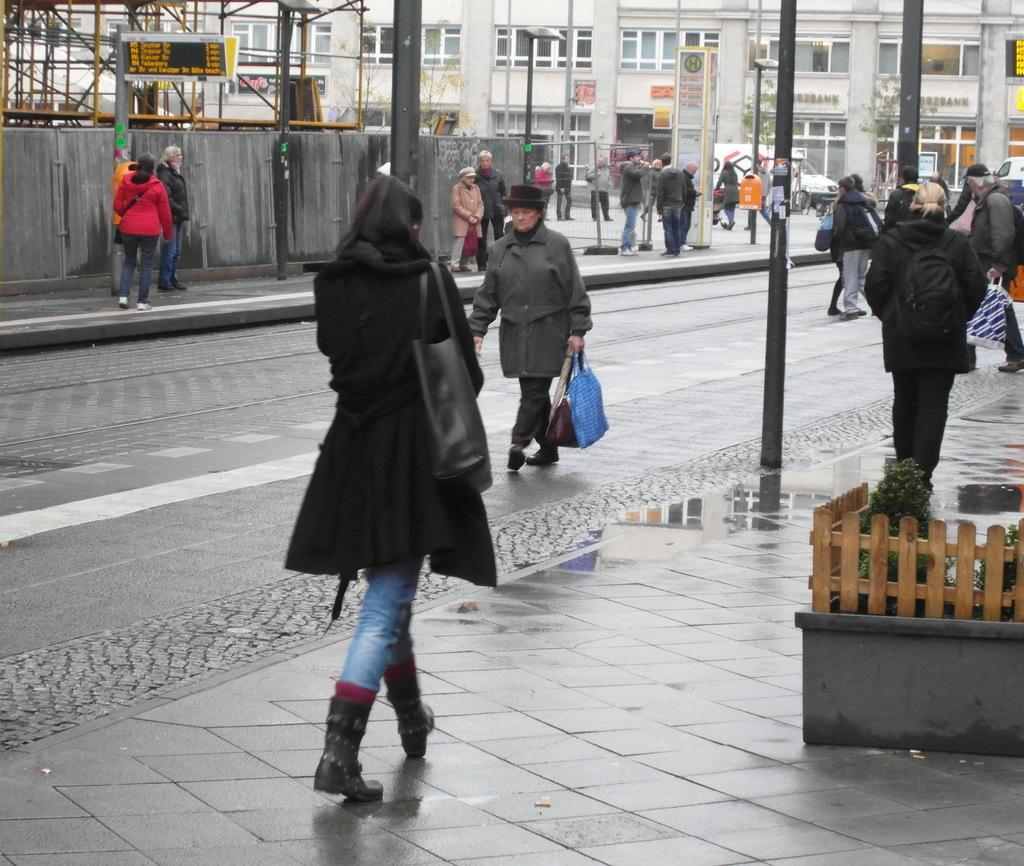What are the people in the image doing? The people in the image are walking on the sidewalk. What type of barrier can be seen in the image? There is a wooden fence in the image. What type of natural elements are present in the image? Plants are present in the image. What type of vertical structures can be seen in the image? There are poles in the image. What type of flat, rigid material is visible in the image? Boards are visible in the image. What type of man-made structures can be seen in the background of the image? Buildings are present in the background of the image. What type of disgust can be seen on the faces of the people in the image? There is no indication of disgust on the faces of the people in the image. What type of business is being conducted in the image? There is no indication of any business being conducted in the image. 